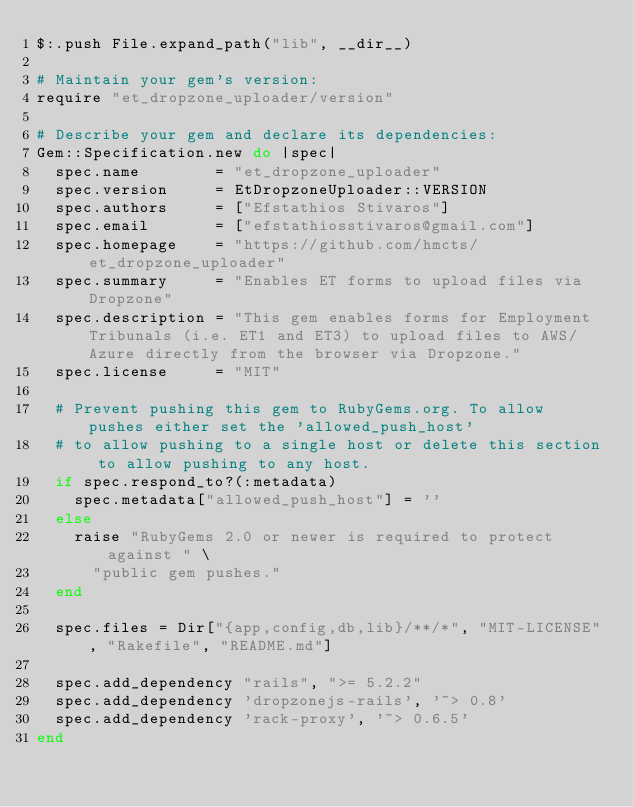<code> <loc_0><loc_0><loc_500><loc_500><_Ruby_>$:.push File.expand_path("lib", __dir__)

# Maintain your gem's version:
require "et_dropzone_uploader/version"

# Describe your gem and declare its dependencies:
Gem::Specification.new do |spec|
  spec.name        = "et_dropzone_uploader"
  spec.version     = EtDropzoneUploader::VERSION
  spec.authors     = ["Efstathios Stivaros"]
  spec.email       = ["efstathiosstivaros@gmail.com"]
  spec.homepage    = "https://github.com/hmcts/et_dropzone_uploader"
  spec.summary     = "Enables ET forms to upload files via Dropzone"
  spec.description = "This gem enables forms for Employment Tribunals (i.e. ET1 and ET3) to upload files to AWS/Azure directly from the browser via Dropzone."
  spec.license     = "MIT"

  # Prevent pushing this gem to RubyGems.org. To allow pushes either set the 'allowed_push_host'
  # to allow pushing to a single host or delete this section to allow pushing to any host.
  if spec.respond_to?(:metadata)
    spec.metadata["allowed_push_host"] = ''
  else
    raise "RubyGems 2.0 or newer is required to protect against " \
      "public gem pushes."
  end

  spec.files = Dir["{app,config,db,lib}/**/*", "MIT-LICENSE", "Rakefile", "README.md"]

  spec.add_dependency "rails", ">= 5.2.2"
  spec.add_dependency 'dropzonejs-rails', '~> 0.8'
  spec.add_dependency 'rack-proxy', '~> 0.6.5'
end
</code> 